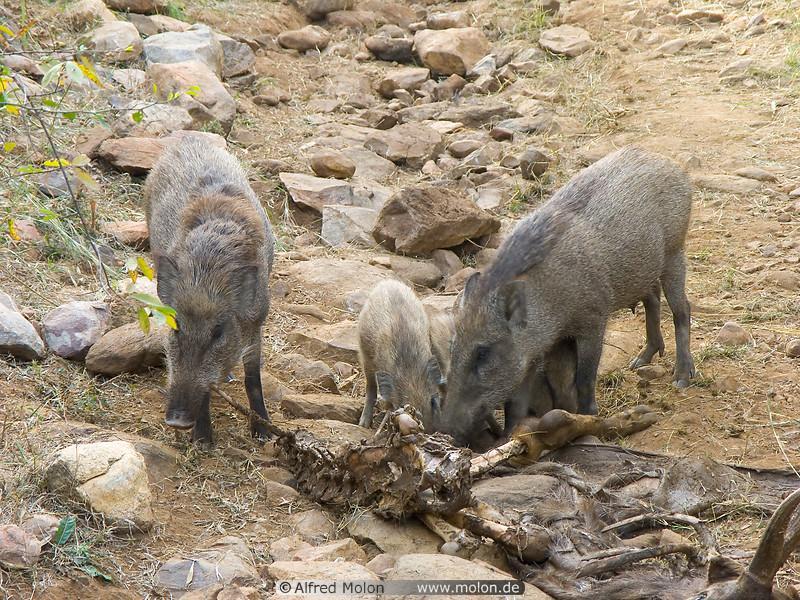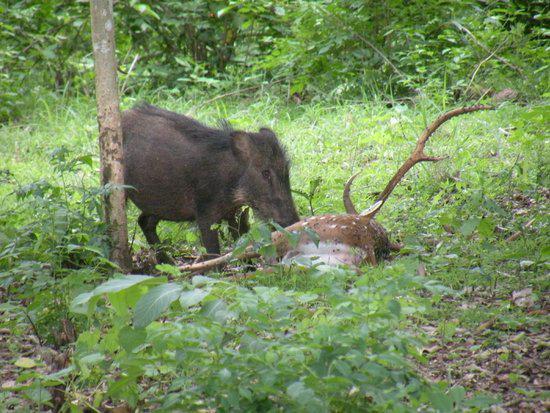The first image is the image on the left, the second image is the image on the right. For the images shown, is this caption "One image shows several striped wild boar piglets sharing a meaty meal with their elders." true? Answer yes or no. No. The first image is the image on the left, the second image is the image on the right. For the images shown, is this caption "Some of the pigs are standing in snow." true? Answer yes or no. No. 